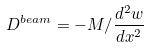Convert formula to latex. <formula><loc_0><loc_0><loc_500><loc_500>D ^ { b e a m } = - M / \frac { d ^ { 2 } w } { d x ^ { 2 } }</formula> 